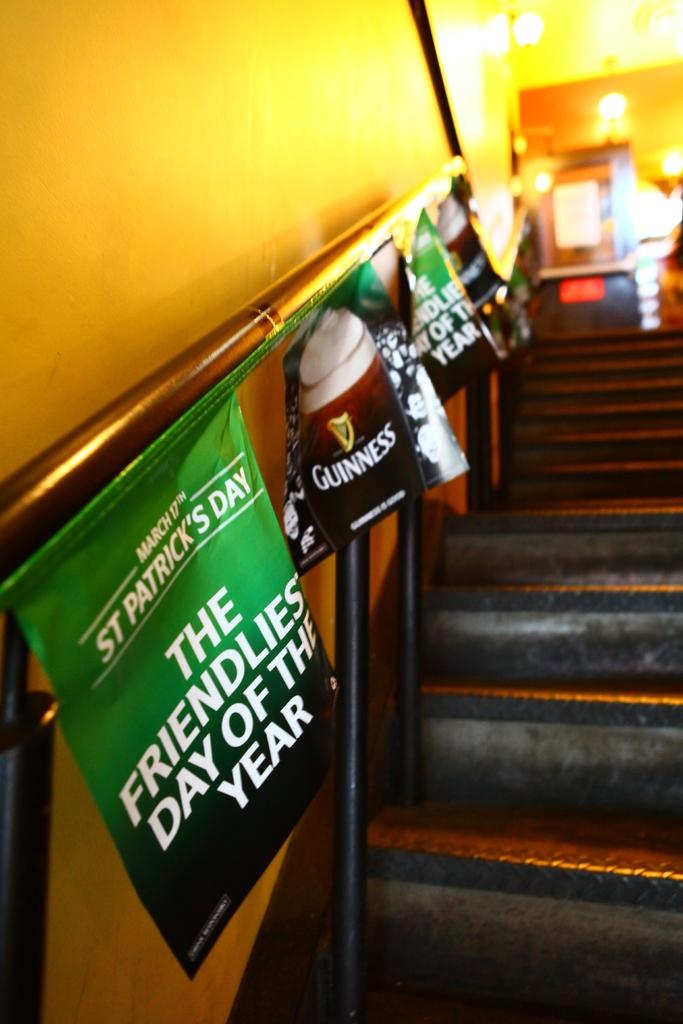<image>
Provide a brief description of the given image. a stair rail with a sign on it that says 'guinness' 